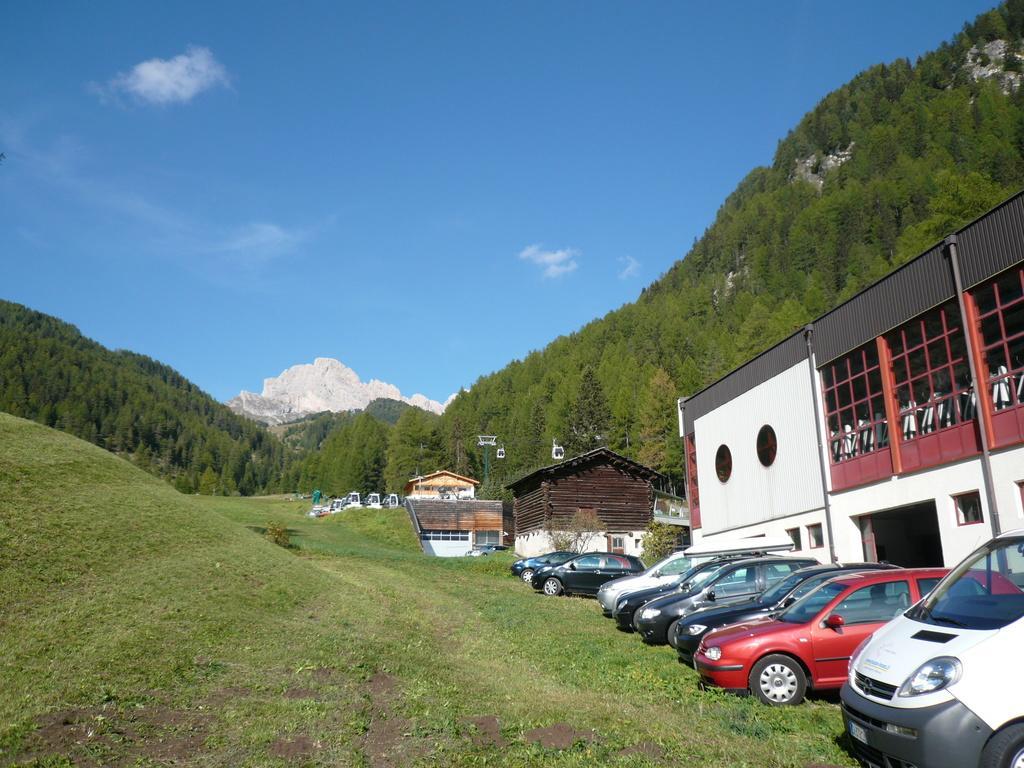Could you give a brief overview of what you see in this image? Here in this picture we can see number of cars present on the ground, which is fully covered with grass over there and we can also see houses present over there and we can see trees surrounded all around that over there and we can see clouds in the sky and in the far we can see mountains present. 